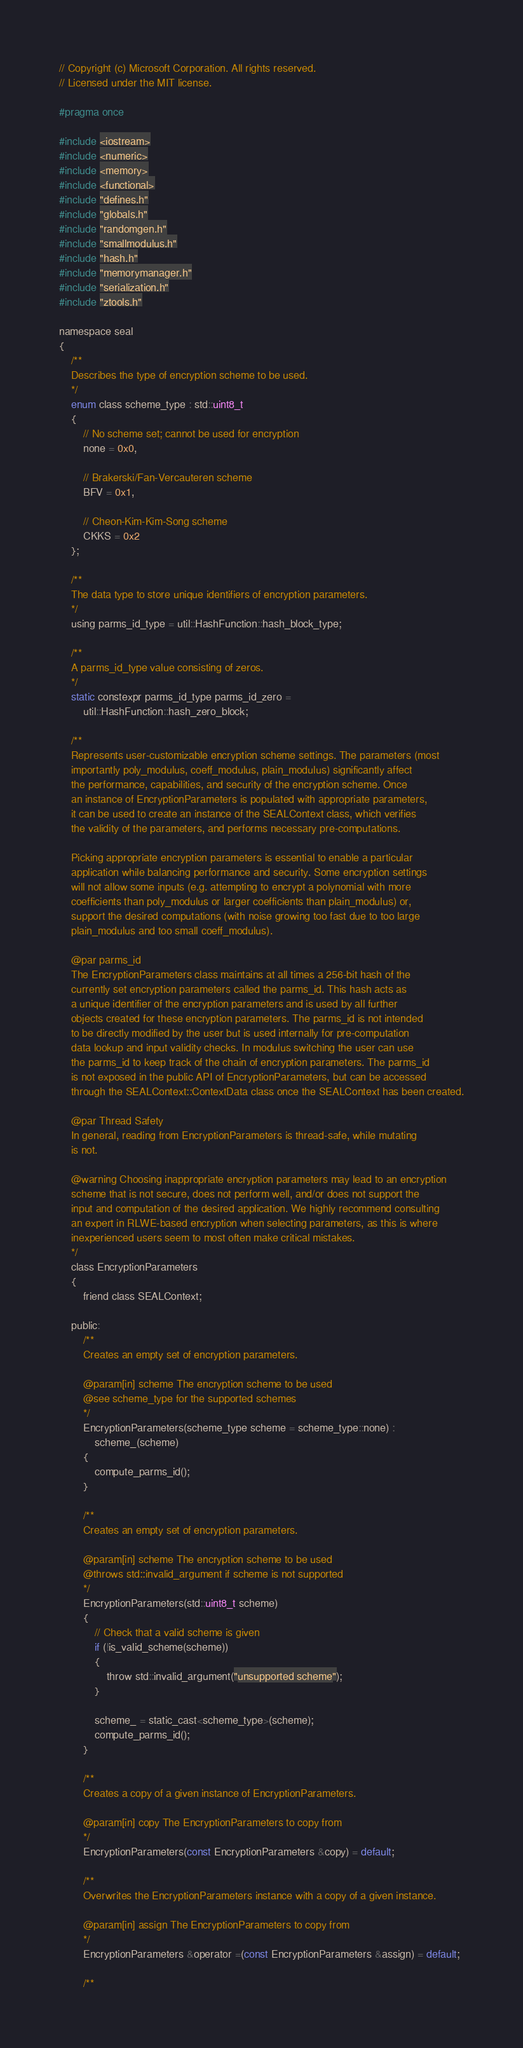Convert code to text. <code><loc_0><loc_0><loc_500><loc_500><_C_>// Copyright (c) Microsoft Corporation. All rights reserved.
// Licensed under the MIT license.

#pragma once

#include <iostream>
#include <numeric>
#include <memory>
#include <functional>
#include "defines.h"
#include "globals.h"
#include "randomgen.h"
#include "smallmodulus.h"
#include "hash.h"
#include "memorymanager.h"
#include "serialization.h"
#include "ztools.h"

namespace seal
{
    /**
    Describes the type of encryption scheme to be used.
    */
    enum class scheme_type : std::uint8_t
    {
        // No scheme set; cannot be used for encryption
        none = 0x0,

        // Brakerski/Fan-Vercauteren scheme
        BFV = 0x1,

        // Cheon-Kim-Kim-Song scheme
        CKKS = 0x2
    };

    /**
    The data type to store unique identifiers of encryption parameters.
    */
    using parms_id_type = util::HashFunction::hash_block_type;

    /**
    A parms_id_type value consisting of zeros.
    */
    static constexpr parms_id_type parms_id_zero =
        util::HashFunction::hash_zero_block;

    /**
    Represents user-customizable encryption scheme settings. The parameters (most
    importantly poly_modulus, coeff_modulus, plain_modulus) significantly affect
    the performance, capabilities, and security of the encryption scheme. Once
    an instance of EncryptionParameters is populated with appropriate parameters,
    it can be used to create an instance of the SEALContext class, which verifies
    the validity of the parameters, and performs necessary pre-computations.

    Picking appropriate encryption parameters is essential to enable a particular
    application while balancing performance and security. Some encryption settings
    will not allow some inputs (e.g. attempting to encrypt a polynomial with more
    coefficients than poly_modulus or larger coefficients than plain_modulus) or,
    support the desired computations (with noise growing too fast due to too large
    plain_modulus and too small coeff_modulus).

    @par parms_id
    The EncryptionParameters class maintains at all times a 256-bit hash of the
    currently set encryption parameters called the parms_id. This hash acts as
    a unique identifier of the encryption parameters and is used by all further
    objects created for these encryption parameters. The parms_id is not intended
    to be directly modified by the user but is used internally for pre-computation
    data lookup and input validity checks. In modulus switching the user can use
    the parms_id to keep track of the chain of encryption parameters. The parms_id
    is not exposed in the public API of EncryptionParameters, but can be accessed
    through the SEALContext::ContextData class once the SEALContext has been created.

    @par Thread Safety
    In general, reading from EncryptionParameters is thread-safe, while mutating
    is not.

    @warning Choosing inappropriate encryption parameters may lead to an encryption
    scheme that is not secure, does not perform well, and/or does not support the
    input and computation of the desired application. We highly recommend consulting
    an expert in RLWE-based encryption when selecting parameters, as this is where
    inexperienced users seem to most often make critical mistakes.
    */
    class EncryptionParameters
    {
        friend class SEALContext;

    public:
        /**
        Creates an empty set of encryption parameters.

        @param[in] scheme The encryption scheme to be used
        @see scheme_type for the supported schemes
        */
        EncryptionParameters(scheme_type scheme = scheme_type::none) :
            scheme_(scheme)
        {
            compute_parms_id();
        }

        /**
        Creates an empty set of encryption parameters.

        @param[in] scheme The encryption scheme to be used
        @throws std::invalid_argument if scheme is not supported
        */
        EncryptionParameters(std::uint8_t scheme)
        {
            // Check that a valid scheme is given
            if (!is_valid_scheme(scheme))
            {
                throw std::invalid_argument("unsupported scheme");
            }

            scheme_ = static_cast<scheme_type>(scheme);
            compute_parms_id();
        }

        /**
        Creates a copy of a given instance of EncryptionParameters.

        @param[in] copy The EncryptionParameters to copy from
        */
        EncryptionParameters(const EncryptionParameters &copy) = default;

        /**
        Overwrites the EncryptionParameters instance with a copy of a given instance.

        @param[in] assign The EncryptionParameters to copy from
        */
        EncryptionParameters &operator =(const EncryptionParameters &assign) = default;

        /**</code> 